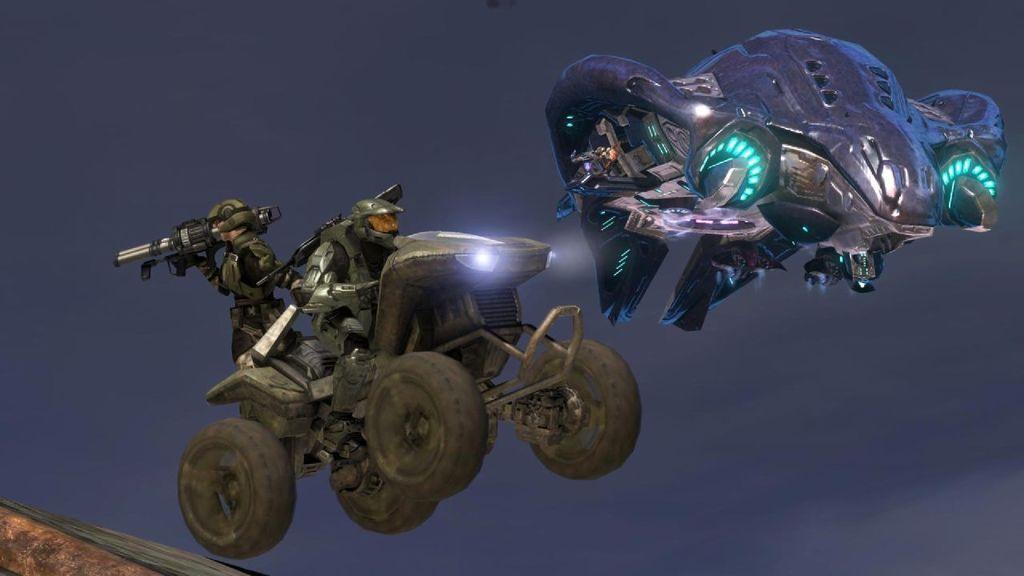Can you describe this image briefly? In this image we can see two animated flying vehicles. Here we can see a person on the jet ski vehicle. Here we can see a person holding the bioscope. 